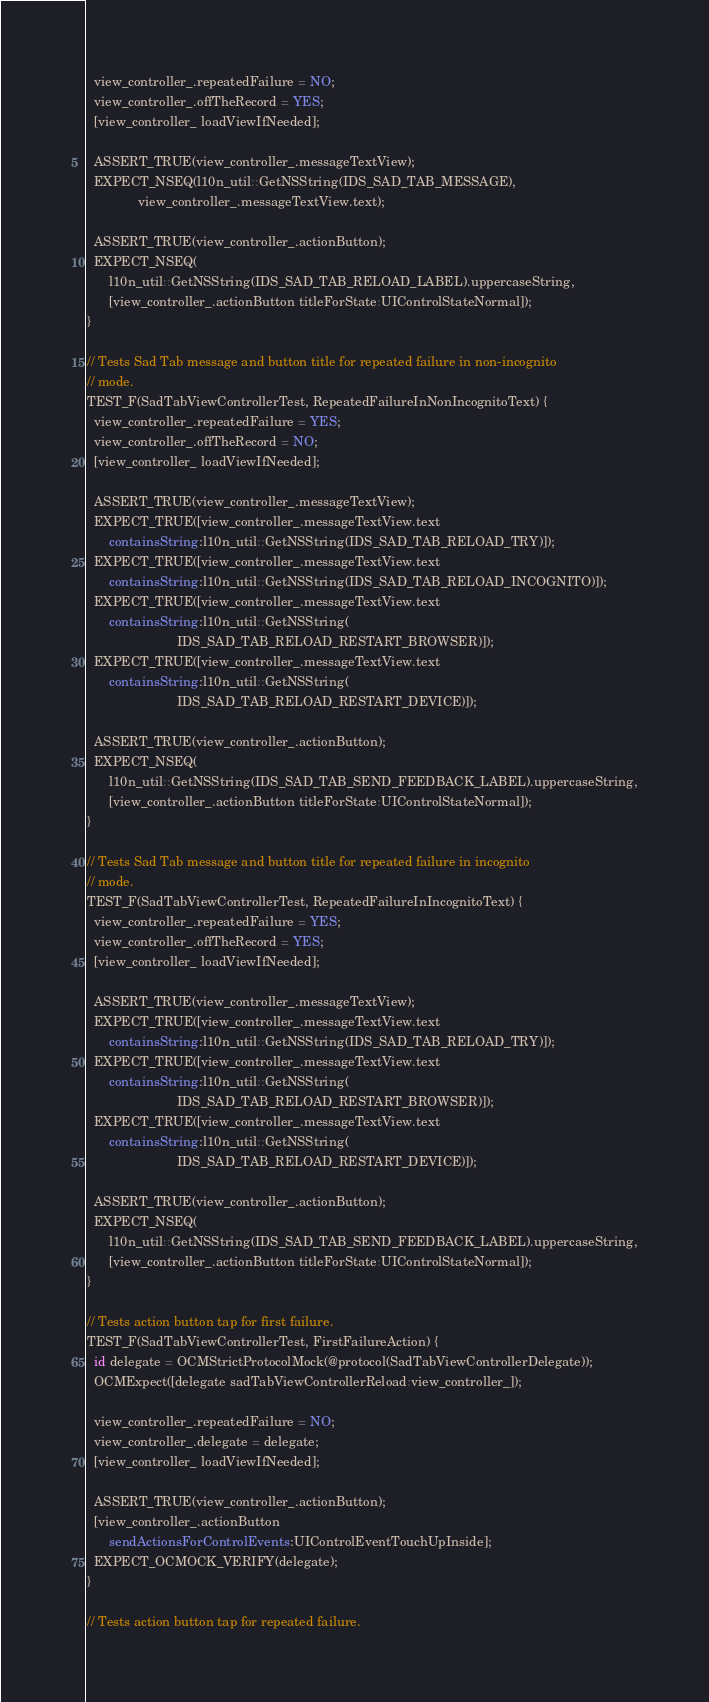<code> <loc_0><loc_0><loc_500><loc_500><_ObjectiveC_>  view_controller_.repeatedFailure = NO;
  view_controller_.offTheRecord = YES;
  [view_controller_ loadViewIfNeeded];

  ASSERT_TRUE(view_controller_.messageTextView);
  EXPECT_NSEQ(l10n_util::GetNSString(IDS_SAD_TAB_MESSAGE),
              view_controller_.messageTextView.text);

  ASSERT_TRUE(view_controller_.actionButton);
  EXPECT_NSEQ(
      l10n_util::GetNSString(IDS_SAD_TAB_RELOAD_LABEL).uppercaseString,
      [view_controller_.actionButton titleForState:UIControlStateNormal]);
}

// Tests Sad Tab message and button title for repeated failure in non-incognito
// mode.
TEST_F(SadTabViewControllerTest, RepeatedFailureInNonIncognitoText) {
  view_controller_.repeatedFailure = YES;
  view_controller_.offTheRecord = NO;
  [view_controller_ loadViewIfNeeded];

  ASSERT_TRUE(view_controller_.messageTextView);
  EXPECT_TRUE([view_controller_.messageTextView.text
      containsString:l10n_util::GetNSString(IDS_SAD_TAB_RELOAD_TRY)]);
  EXPECT_TRUE([view_controller_.messageTextView.text
      containsString:l10n_util::GetNSString(IDS_SAD_TAB_RELOAD_INCOGNITO)]);
  EXPECT_TRUE([view_controller_.messageTextView.text
      containsString:l10n_util::GetNSString(
                         IDS_SAD_TAB_RELOAD_RESTART_BROWSER)]);
  EXPECT_TRUE([view_controller_.messageTextView.text
      containsString:l10n_util::GetNSString(
                         IDS_SAD_TAB_RELOAD_RESTART_DEVICE)]);

  ASSERT_TRUE(view_controller_.actionButton);
  EXPECT_NSEQ(
      l10n_util::GetNSString(IDS_SAD_TAB_SEND_FEEDBACK_LABEL).uppercaseString,
      [view_controller_.actionButton titleForState:UIControlStateNormal]);
}

// Tests Sad Tab message and button title for repeated failure in incognito
// mode.
TEST_F(SadTabViewControllerTest, RepeatedFailureInIncognitoText) {
  view_controller_.repeatedFailure = YES;
  view_controller_.offTheRecord = YES;
  [view_controller_ loadViewIfNeeded];

  ASSERT_TRUE(view_controller_.messageTextView);
  EXPECT_TRUE([view_controller_.messageTextView.text
      containsString:l10n_util::GetNSString(IDS_SAD_TAB_RELOAD_TRY)]);
  EXPECT_TRUE([view_controller_.messageTextView.text
      containsString:l10n_util::GetNSString(
                         IDS_SAD_TAB_RELOAD_RESTART_BROWSER)]);
  EXPECT_TRUE([view_controller_.messageTextView.text
      containsString:l10n_util::GetNSString(
                         IDS_SAD_TAB_RELOAD_RESTART_DEVICE)]);

  ASSERT_TRUE(view_controller_.actionButton);
  EXPECT_NSEQ(
      l10n_util::GetNSString(IDS_SAD_TAB_SEND_FEEDBACK_LABEL).uppercaseString,
      [view_controller_.actionButton titleForState:UIControlStateNormal]);
}

// Tests action button tap for first failure.
TEST_F(SadTabViewControllerTest, FirstFailureAction) {
  id delegate = OCMStrictProtocolMock(@protocol(SadTabViewControllerDelegate));
  OCMExpect([delegate sadTabViewControllerReload:view_controller_]);

  view_controller_.repeatedFailure = NO;
  view_controller_.delegate = delegate;
  [view_controller_ loadViewIfNeeded];

  ASSERT_TRUE(view_controller_.actionButton);
  [view_controller_.actionButton
      sendActionsForControlEvents:UIControlEventTouchUpInside];
  EXPECT_OCMOCK_VERIFY(delegate);
}

// Tests action button tap for repeated failure.</code> 